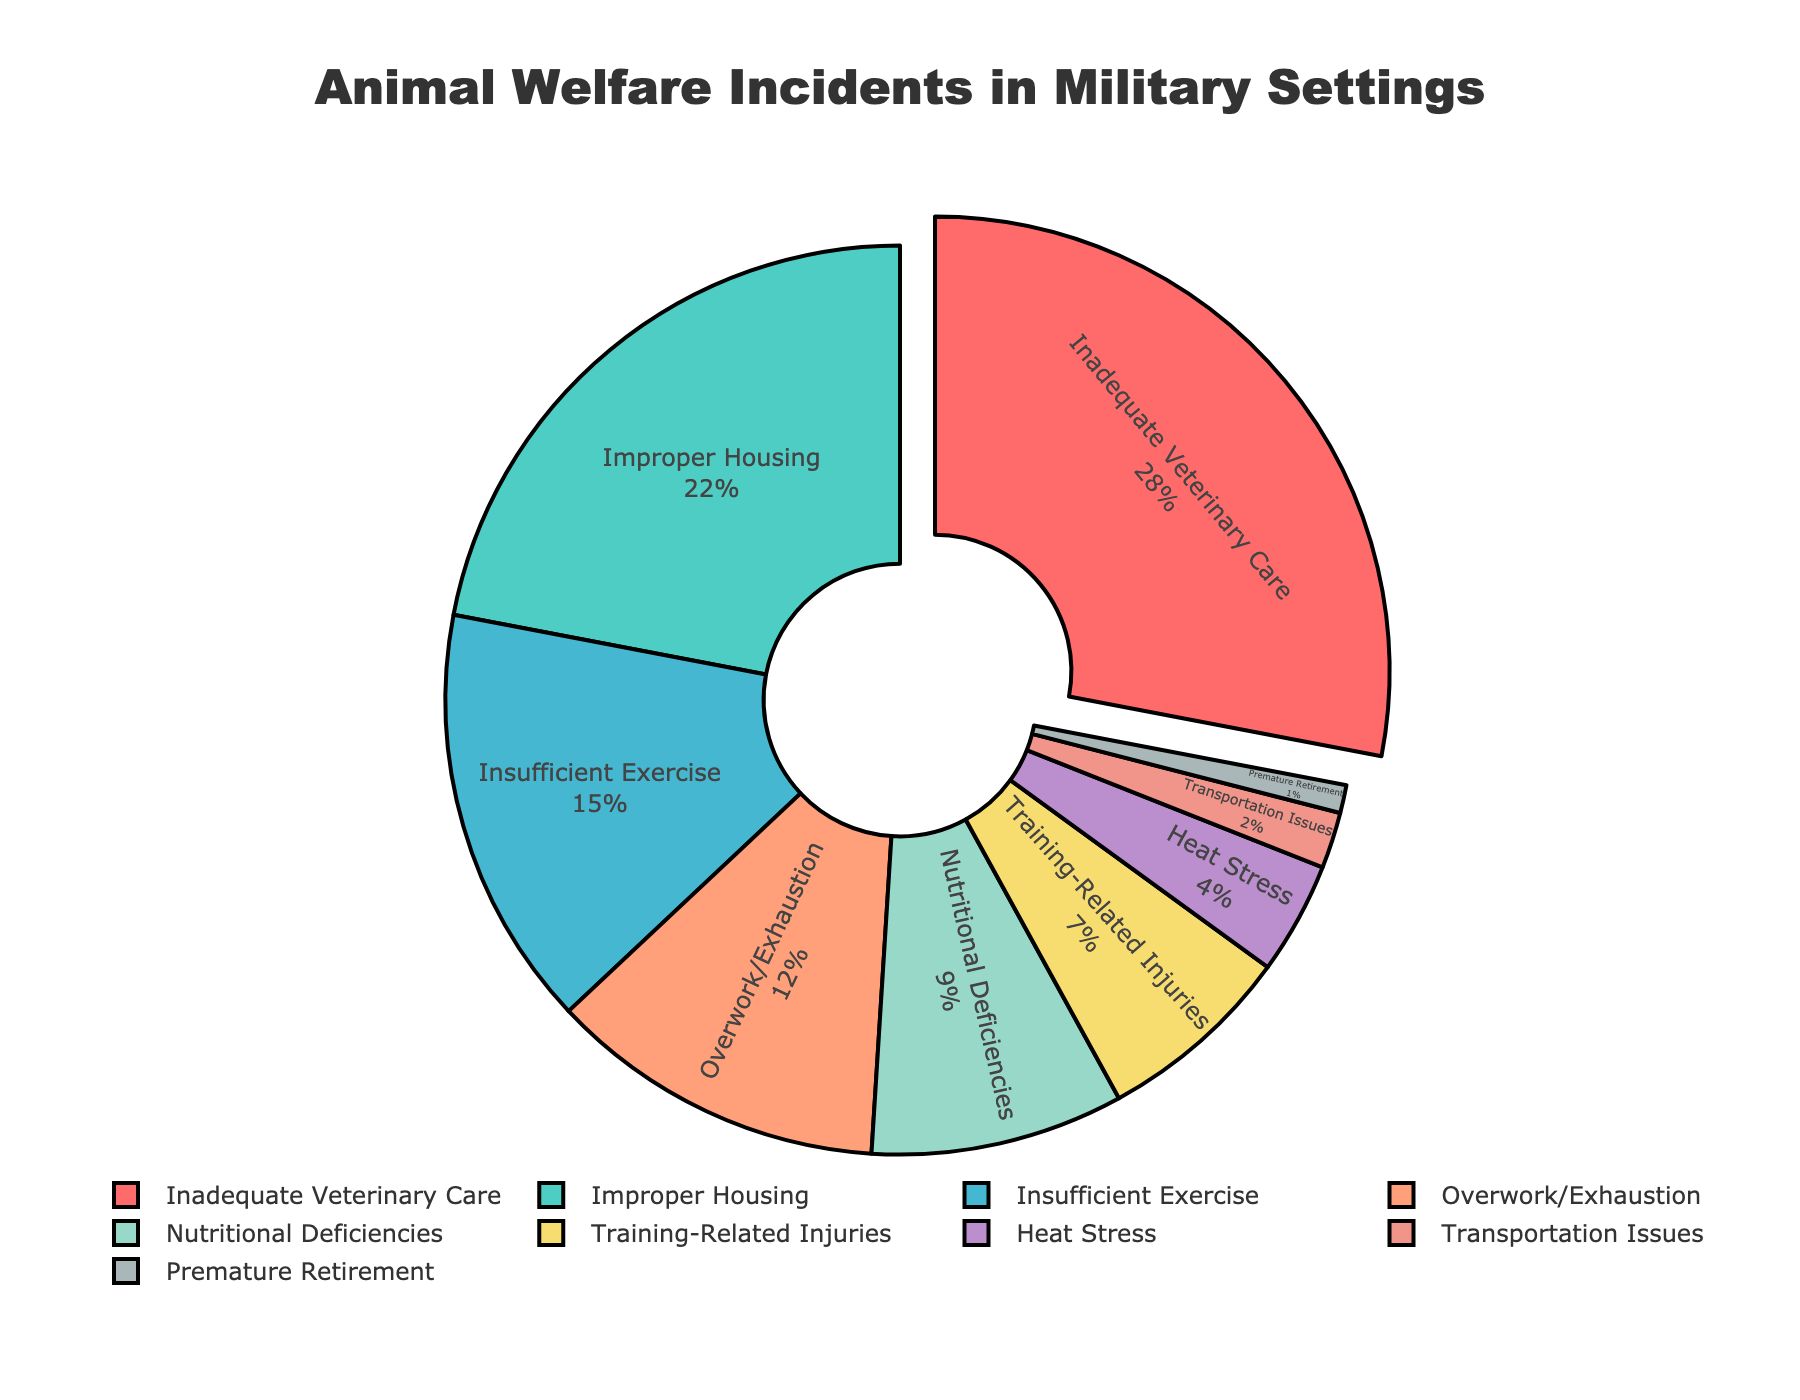Which type of incident has the highest percentage? The figure shows a pie chart with the largest segment representing the type of incident with the highest percentage. "Inadequate Veterinary Care" has the largest segment.
Answer: Inadequate Veterinary Care Which two incident types together account for exactly 50% of the reported incidents? Adding the percentages of the incident types "Inadequate Veterinary Care" (28%) and "Improper Housing" (22%) results in a total of 50%.
Answer: Inadequate Veterinary Care and Improper Housing What percentage of incidents are related to "Insufficient Exercise" and "Training-Related Injuries" combined? The percentages of "Insufficient Exercise" and "Training-Related Injuries" are 15% and 7% respectively. Adding them gives 15% + 7% = 22%.
Answer: 22% Which type of incident has a percentage closest to 10%? Comparing the percentages, "Nutritional Deficiencies" has 9%, which is closest to 10%. No other category has a percentage closer.
Answer: Nutritional Deficiencies How much more common is "Inadequate Veterinary Care" compared to "Overwork/Exhaustion"? The percentage of "Inadequate Veterinary Care" is 28%, and "Overwork/Exhaustion" is 12%. The difference is 28% - 12% = 16%.
Answer: 16% Which incidents account for less than 10% each? The segments representing less than 10% each are those for "Nutritional Deficiencies" (9%), "Training-Related Injuries" (7%), "Heat Stress" (4%), "Transportation Issues" (2%), and "Premature Retirement" (1%).
Answer: Nutritional Deficiencies, Training-Related Injuries, Heat Stress, Transportation Issues, Premature Retirement What is the total percentage for incidents related to "Housing," "Exercise," and "Veterinary Care"? Adding the percentages of "Improper Housing" (22%), "Insufficient Exercise" (15%), and "Inadequate Veterinary Care" (28%) results in 22% + 15% + 28% = 65%.
Answer: 65% Which color represents "Heat Stress" and what is its percentage? "Heat Stress" is represented by a specific color in the chart. By referring to the visual attributes, "Heat Stress" is marked in light purple with a percentage of 4%.
Answer: Light purple; 4% Is "Transportation Issues" more or less common than "Premature Retirement"? Comparing the percentages, "Transportation Issues" accounts for 2%, whereas "Premature Retirement" accounts for 1%. Therefore, "Transportation Issues" is more common.
Answer: More common What percentage of incident types have a percentage greater than 20%? Both "Inadequate Veterinary Care" (28%) and "Improper Housing" (22%) have percentages greater than 20%. Hence, the total number is 2 types.
Answer: 2 types 